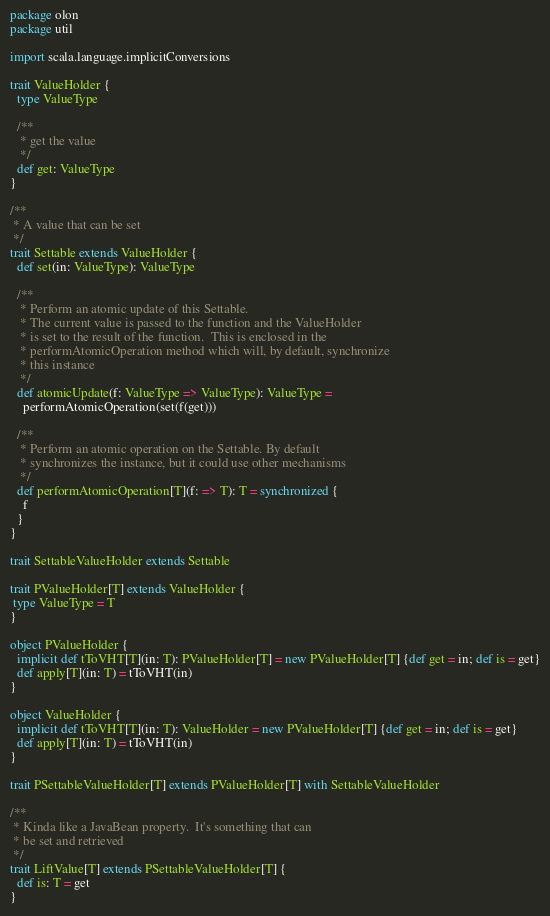<code> <loc_0><loc_0><loc_500><loc_500><_Scala_>package olon 
package util 

import scala.language.implicitConversions

trait ValueHolder {
  type ValueType

  /**
   * get the value
   */
  def get: ValueType
}

/**
 * A value that can be set
 */
trait Settable extends ValueHolder {
  def set(in: ValueType): ValueType

  /**
   * Perform an atomic update of this Settable.
   * The current value is passed to the function and the ValueHolder
   * is set to the result of the function.  This is enclosed in the
   * performAtomicOperation method which will, by default, synchronize
   * this instance
   */
  def atomicUpdate(f: ValueType => ValueType): ValueType =
    performAtomicOperation(set(f(get)))

  /**
   * Perform an atomic operation on the Settable. By default
   * synchronizes the instance, but it could use other mechanisms
   */
  def performAtomicOperation[T](f: => T): T = synchronized {
    f
  }
}

trait SettableValueHolder extends Settable

trait PValueHolder[T] extends ValueHolder {
 type ValueType = T
}

object PValueHolder {
  implicit def tToVHT[T](in: T): PValueHolder[T] = new PValueHolder[T] {def get = in; def is = get}
  def apply[T](in: T) = tToVHT(in)
}

object ValueHolder {
  implicit def tToVHT[T](in: T): ValueHolder = new PValueHolder[T] {def get = in; def is = get}
  def apply[T](in: T) = tToVHT(in)
}

trait PSettableValueHolder[T] extends PValueHolder[T] with SettableValueHolder

/**
 * Kinda like a JavaBean property.  It's something that can
 * be set and retrieved
 */
trait LiftValue[T] extends PSettableValueHolder[T] {
  def is: T = get
}

</code> 